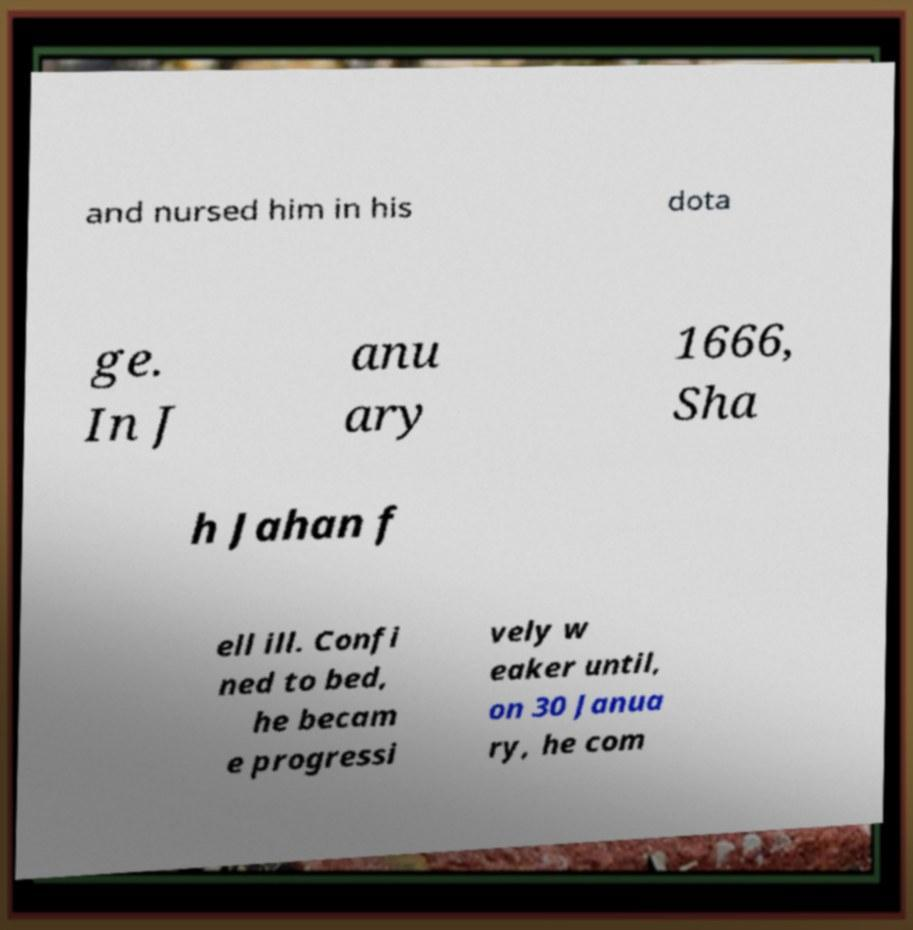For documentation purposes, I need the text within this image transcribed. Could you provide that? and nursed him in his dota ge. In J anu ary 1666, Sha h Jahan f ell ill. Confi ned to bed, he becam e progressi vely w eaker until, on 30 Janua ry, he com 